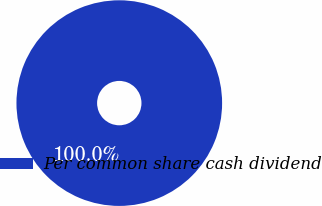Convert chart to OTSL. <chart><loc_0><loc_0><loc_500><loc_500><pie_chart><fcel>Per common share cash dividend<nl><fcel>100.0%<nl></chart> 